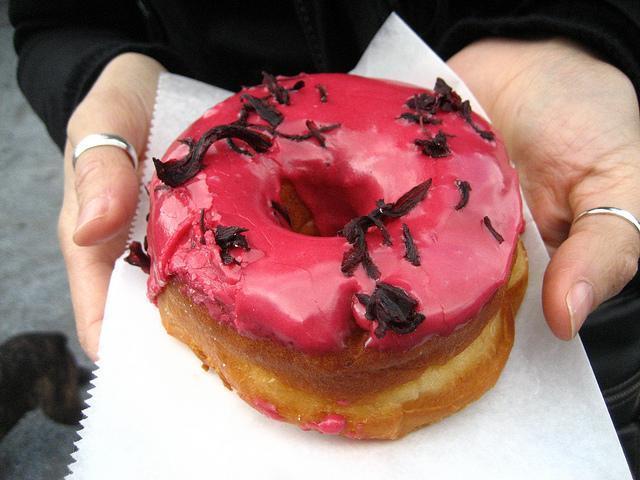How many rings is this person holding?
Give a very brief answer. 2. How many silver cars are in the image?
Give a very brief answer. 0. 